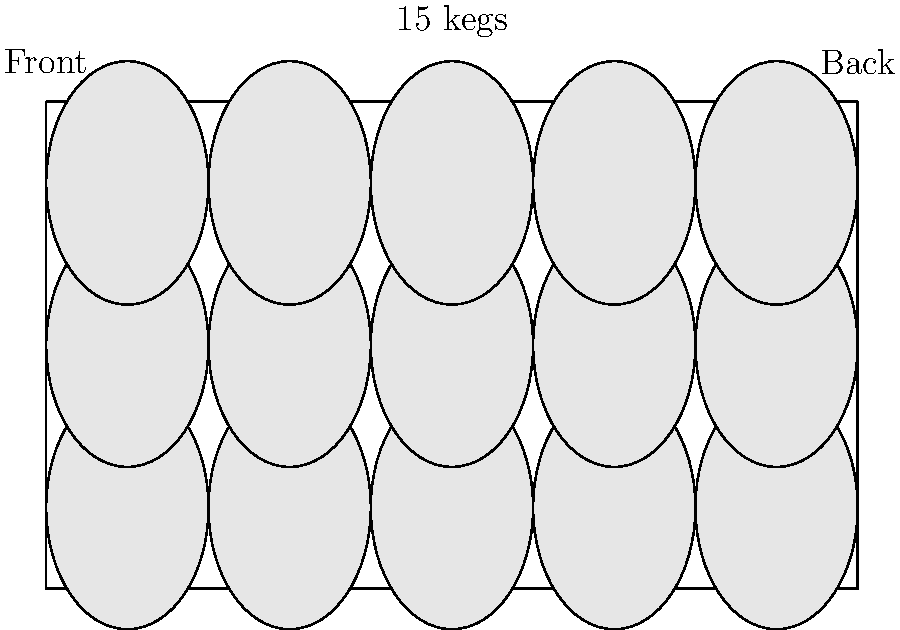Based on the visual representation of keg placement in the delivery truck, estimate the total weight of the loaded truck. Given that each empty keg weighs 30 lbs, each keg contains 15.5 gallons of beer, a gallon of beer weighs 8.34 lbs, and the empty truck weighs 10,000 lbs, what is the approximate total weight of the loaded truck? Let's break this down step-by-step:

1. Count the number of kegs:
   From the diagram, we can see there are 15 kegs loaded.

2. Calculate the weight of beer in each keg:
   $15.5 \text{ gallons} \times 8.34 \text{ lbs/gallon} = 129.27 \text{ lbs}$ of beer per keg

3. Calculate the total weight of each loaded keg:
   $30 \text{ lbs (empty keg)} + 129.27 \text{ lbs (beer)} = 159.27 \text{ lbs}$ per loaded keg

4. Calculate the total weight of all loaded kegs:
   $15 \text{ kegs} \times 159.27 \text{ lbs} = 2,389.05 \text{ lbs}$

5. Add the weight of the loaded kegs to the empty truck weight:
   $10,000 \text{ lbs (empty truck)} + 2,389.05 \text{ lbs (loaded kegs)} = 12,389.05 \text{ lbs}$

6. Round to a reasonable precision for estimation:
   $12,389.05 \text{ lbs} \approx 12,400 \text{ lbs}$
Answer: 12,400 lbs 